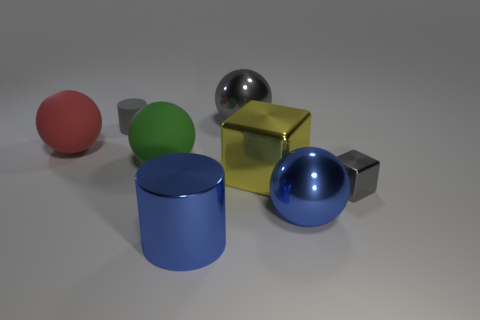Subtract all big red spheres. How many spheres are left? 3 Subtract all blue balls. How many balls are left? 3 Add 2 blue things. How many objects exist? 10 Subtract all cyan spheres. Subtract all red cylinders. How many spheres are left? 4 Subtract all blocks. How many objects are left? 6 Add 4 matte spheres. How many matte spheres are left? 6 Add 4 gray things. How many gray things exist? 7 Subtract 0 cyan cylinders. How many objects are left? 8 Subtract all small cylinders. Subtract all large green things. How many objects are left? 6 